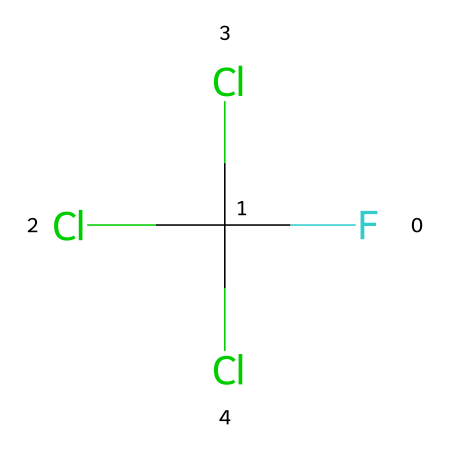What is the name of this chemical? This SMILES representation corresponds to a chlorofluorocarbon (CFC) with four halogen atoms attached to a carbon atom. The naming convention for this molecule usually falls under the category of CFCs.
Answer: chlorofluorocarbon How many chlorine atoms are present in this structure? By analyzing the SMILES, there are three chlorine (Cl) atoms connected to the carbon atom. Counting these gives us a total of three.
Answer: three What is the primary environmental concern related to chlorofluorocarbons? Chlorofluorocarbons are primarily known for their role in stratospheric ozone depletion, which leads to increased ultraviolet radiation reaching the Earth.
Answer: ozone depletion What type of bonds does this chemical primarily consist of? Observing the structure, the chemical contains carbon-chlorine (C-Cl) bonds as the primary type, along with a carbon-fluorine (C-F) bond. This indicates it is an organohalogen compound.
Answer: C-Cl and C-F bonds How many total atoms are in this molecule? The structure consists of one carbon atom, three chlorine atoms, and one fluorine atom, totaling five atoms when added together.
Answer: five What property of CFCs makes them effective refrigerants? The chemical structure of chlorofluorocarbons, particularly their low boiling points and high stability, allows them to function effectively as refrigerants in cooling systems.
Answer: low boiling points What regulatory action has been taken regarding CFCs? The Montreal Protocol has been implemented globally to reduce and phase out the use of CFCs due to their environmental impact on ozone depletion.
Answer: Montreal Protocol 